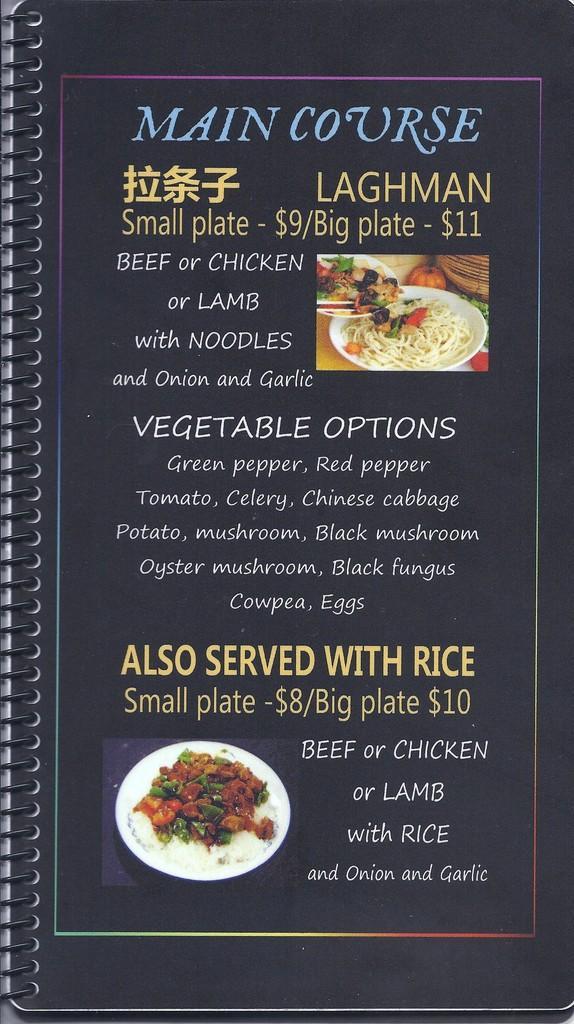In one or two sentences, can you explain what this image depicts? In this picture I can observe a cover page of a book. There is some text on this page. I can observe blue, yellow and pink color text on black background. On the left side there is spiral binding. 